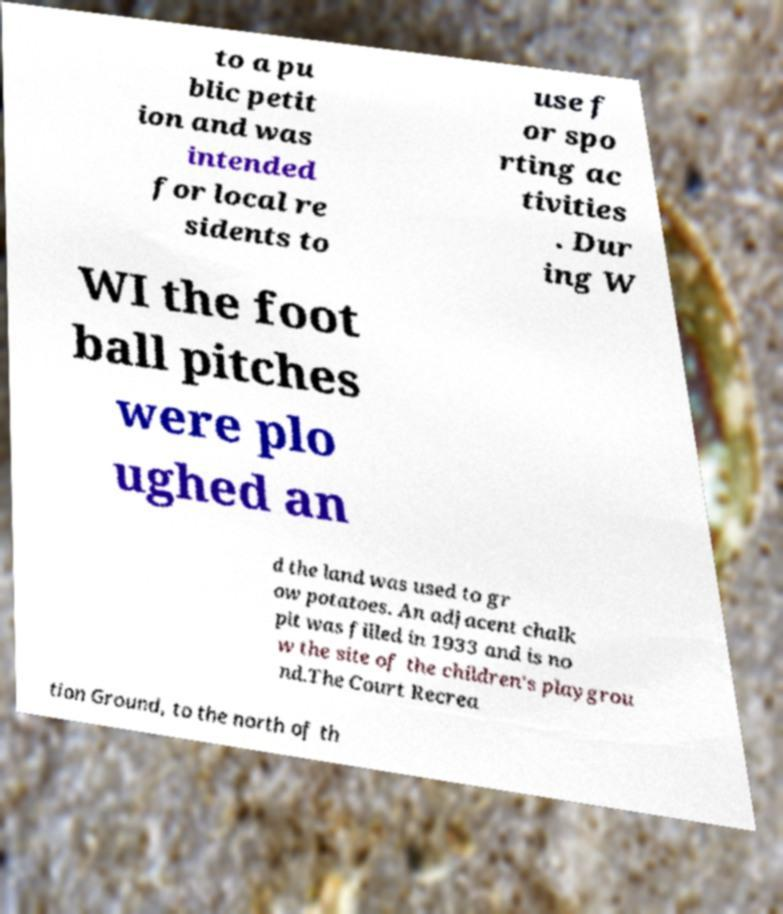I need the written content from this picture converted into text. Can you do that? to a pu blic petit ion and was intended for local re sidents to use f or spo rting ac tivities . Dur ing W WI the foot ball pitches were plo ughed an d the land was used to gr ow potatoes. An adjacent chalk pit was filled in 1933 and is no w the site of the children's playgrou nd.The Court Recrea tion Ground, to the north of th 